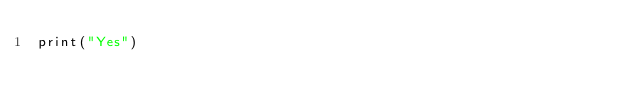<code> <loc_0><loc_0><loc_500><loc_500><_Python_>print("Yes")</code> 